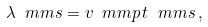<formula> <loc_0><loc_0><loc_500><loc_500>\lambda _ { \ } m m { s } = v _ { \ } m m { p } \, t _ { \ } m m { s } \, ,</formula> 